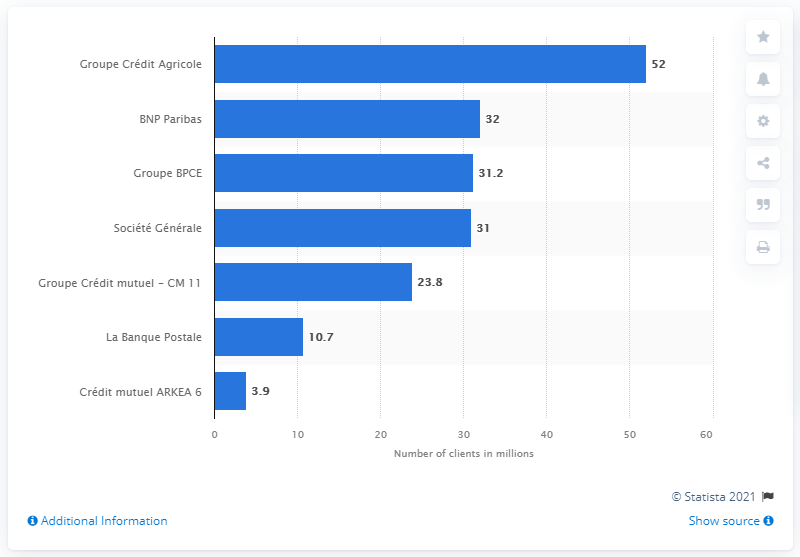Specify some key components in this picture. In 2017, the Credit Agricole Group had 52 clients. 